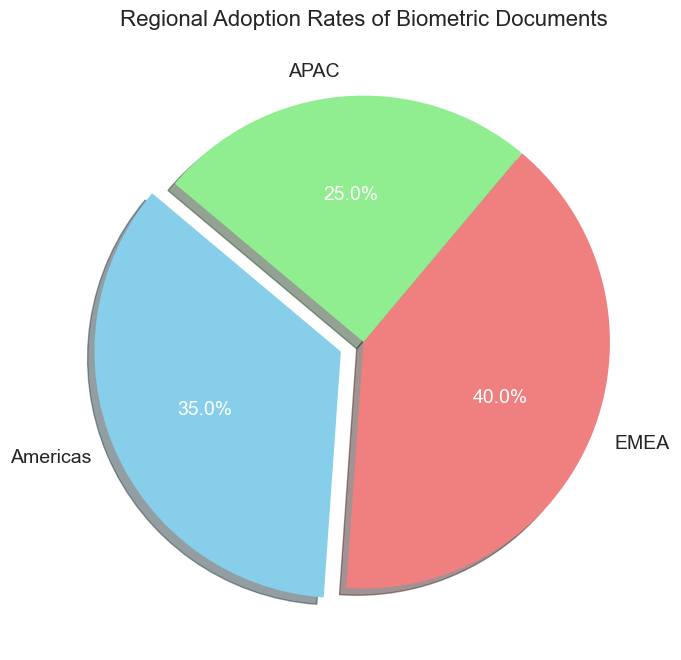What percentage of the adoption rate is from the Americas? The Americas segment of the pie chart shows a slice that represents 35% of the total adoption rate. This is also labeled on the slice itself.
Answer: 35% Which region has the highest adoption rate? The EMEA region has the largest slice in the pie chart, representing 40% of the total adoption rate, making it the highest among the three regions.
Answer: EMEA What is the difference in adoption rates between EMEA and APAC? The adoption rate for EMEA is 40% and for APAC is 25%. The difference is calculated as 40% - 25%.
Answer: 15% Which region's adoption rate is depicted in light green? The APAC region is depicted in light green, as shown in the figure legend or pie slice color.
Answer: APAC If we combine the adoption rates from the Americas and APAC, what would be their total percentage? The adoption rate for the Americas is 35% and for APAC is 25%. Adding them together gives us 35% + 25%.
Answer: 60% By how much does the Americas' adoption rate exceed the APAC's adoption rate? The adoption rate for the Americas is 35%, whereas for APAC it is 25%. The excess amount is calculated as 35% - 25%.
Answer: 10% Is the adoption rate of EMEA more than double that of APAC? The adoption rate for EMEA is 40%, and for APAC it is 25%. To check if EMEA's rate is more than double, calculate if 40% > 2 * 25%. Since 40% is not greater than 50%, EMEA is not more than double.
Answer: No What percentage of the adoption rate comes from regions outside EMEA? The total adoption rate is 100%. EMEA's adoption rate is 40%. The percentage from non-EMEA regions is 100% - 40%.
Answer: 60% Which region's adoption rate is represented by a "skyblue" color? The Americas region is depicted with the "skyblue" color in the pie chart.
Answer: Americas What is the sum of the adoption rates for all regions? The sum is the total percentage represented by all three regions combined, which adds up to 100% by definition in a pie chart.
Answer: 100% 